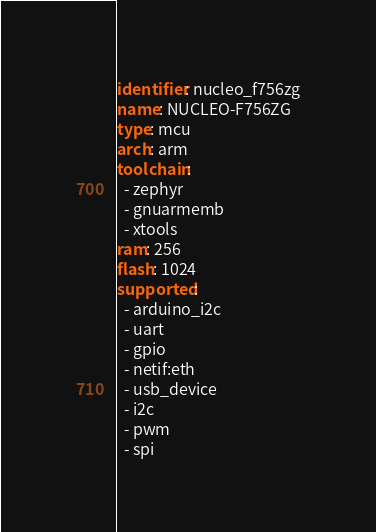<code> <loc_0><loc_0><loc_500><loc_500><_YAML_>identifier: nucleo_f756zg
name: NUCLEO-F756ZG
type: mcu
arch: arm
toolchain:
  - zephyr
  - gnuarmemb
  - xtools
ram: 256
flash: 1024
supported:
  - arduino_i2c
  - uart
  - gpio
  - netif:eth
  - usb_device
  - i2c
  - pwm
  - spi
</code> 